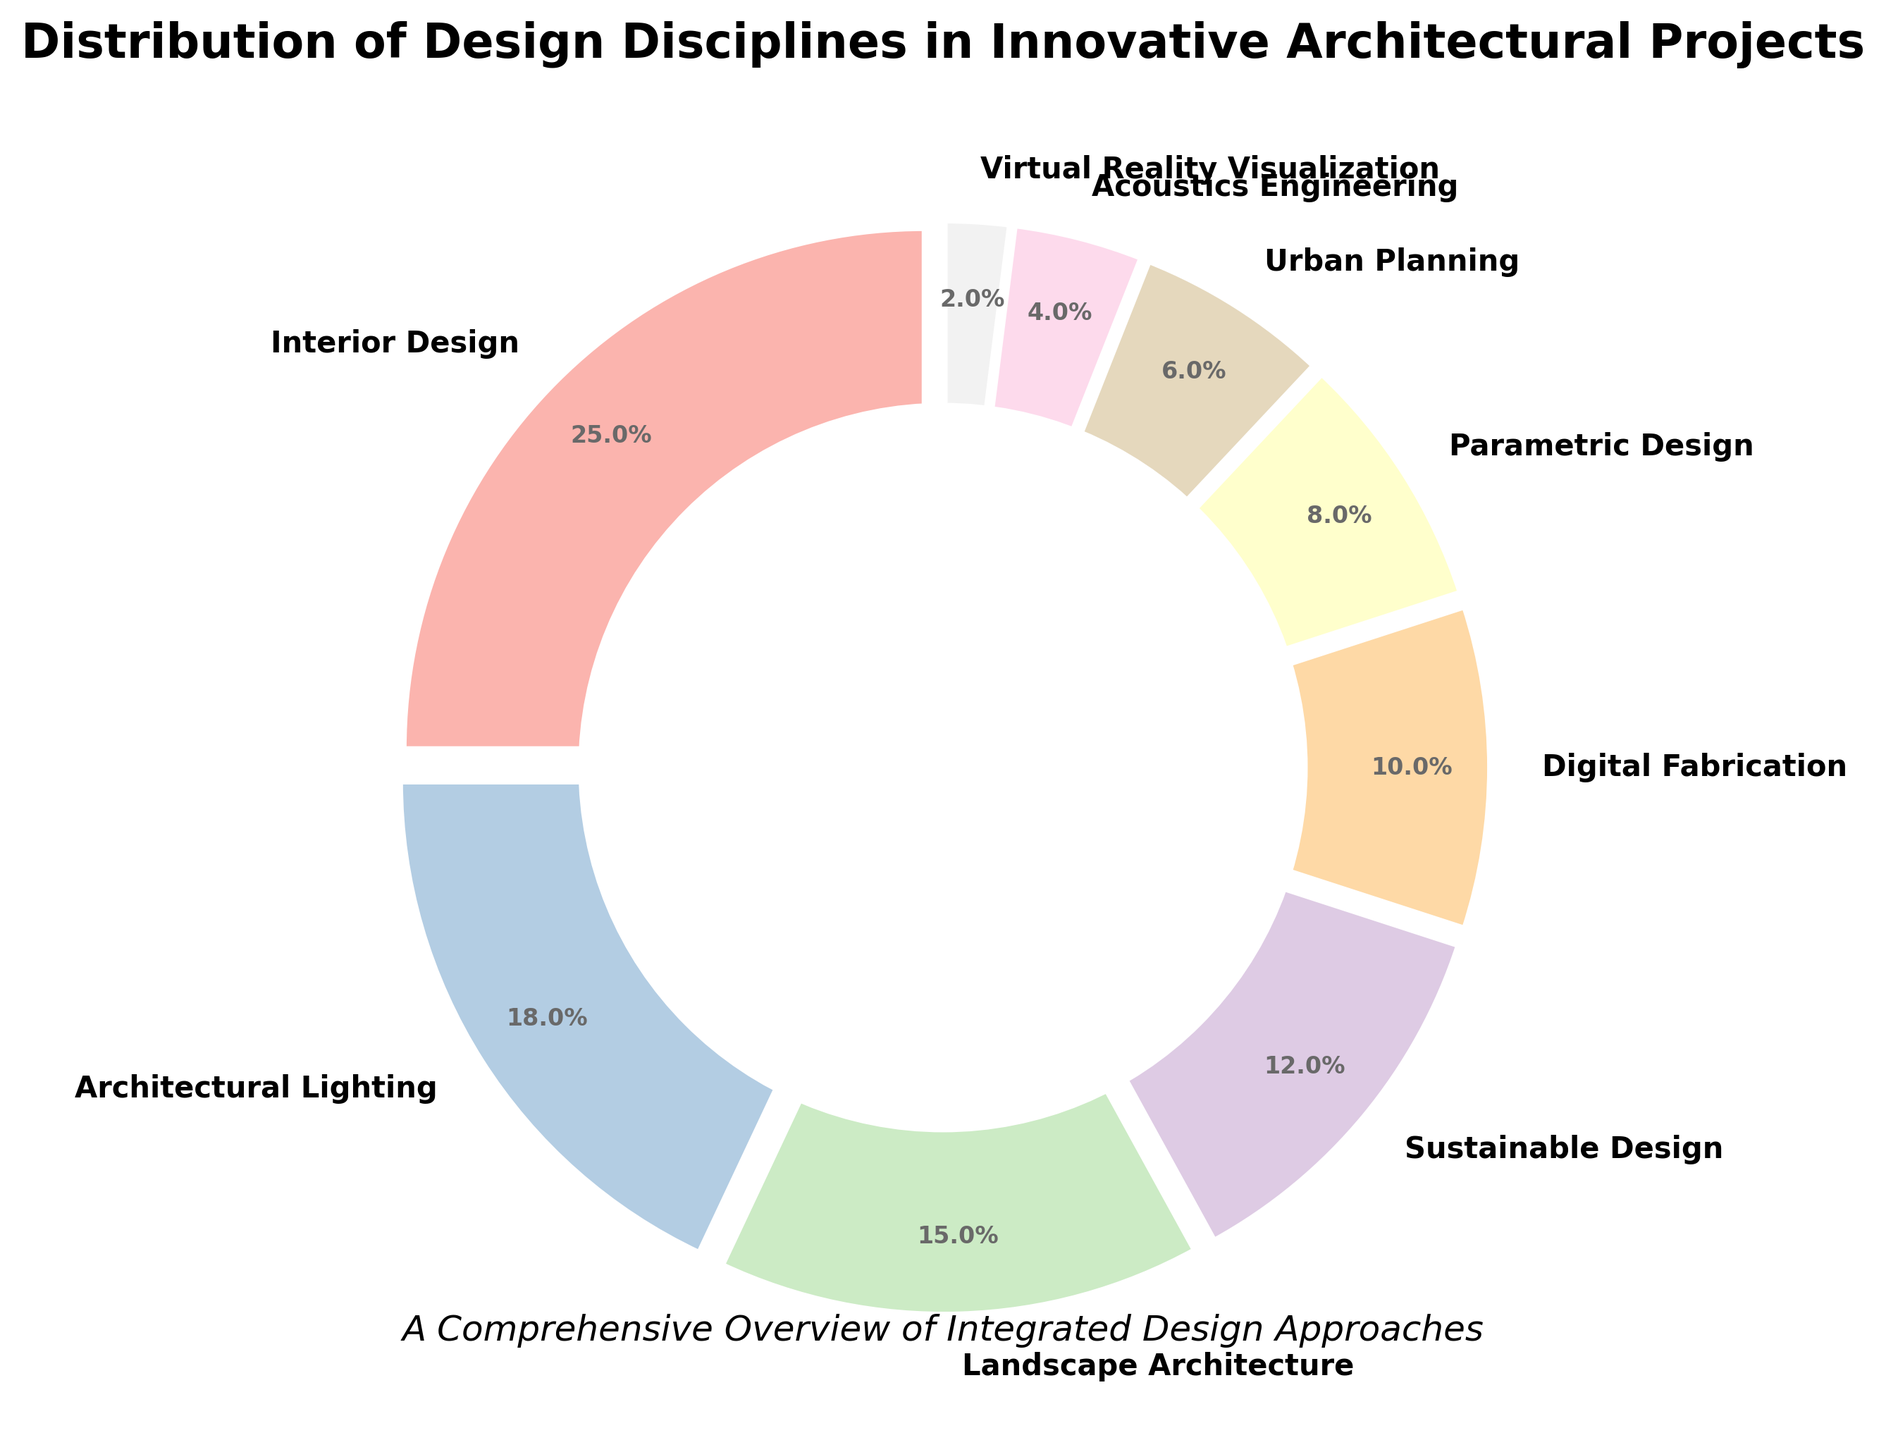Which discipline has the highest percentage? By looking at the pie chart, observe which section is largest. The "Interior Design" section occupies the most space in the chart.
Answer: Interior Design How much more percentage does Interior Design have compared to Urban Planning? The Interior Design section shows 25%, and the Urban Planning section shows 6%. Calculating the difference: 25% - 6% = 19%.
Answer: 19% What is the combined percentage of Sustainable Design and Digital Fabrication? Identifying the percentages from the chart: 12% for Sustainable Design and 10% for Digital Fabrication. Adding them together: 12% + 10% = 22%.
Answer: 22% Which two disciplines together make up half of the total percentage? The chart shows that Interior Design makes up 25% and Architectural Lighting makes up 18%. Combining the two: 25% + 18% = 43%. Interior Design and Landscape Architecture, which is 25% + 15% = 40%, is close too. Hence, no exact pair sums up to 50%, but Interior Design and Architectural Lighting sum up closest to half.
Answer: None How much less is the percentage of Parametric Design compared to Landscape Architecture? The chart shows Parametric Design at 8% and Landscape Architecture at 15%. Calculating the difference: 15% - 8% = 7%.
Answer: 7% Which discipline has the smallest percentage? By looking at the pie chart, observe the smallest section. The "Virtual Reality Visualization" section is the smallest.
Answer: Virtual Reality Visualization What is the total percentage of disciplines focusing on various forms of design (Interior Design, Sustainable Design, Parametric Design, Digital Fabrication)? The chart shows percentages for Interior Design (25%), Sustainable Design (12%), Parametric Design (8%), and Digital Fabrication (10%). Summing these: 25% + 12% + 8% + 10% = 55%.
Answer: 55% How does the percentage of Acoustics Engineering compare to that of Urban Planning? Acoustics Engineering shows 4% while Urban Planning shows 6%. Thus, Acoustics Engineering is less by 2%.
Answer: Less by 2% Compare the combined percentage of Architectural Lighting and Urban Planning to the combined percentage of Landscape Architecture and Acoustics Engineering. Architectural Lighting is 18% and Urban Planning is 6%. Their combined percentage: 18% + 6% = 24%. Landscape Architecture is 15% and Acoustics Engineering is 4%. Their combined percentage: 15% + 4% = 19%. Hence, 24% is greater than 19%.
Answer: Architectural Lighting and Urban Planning combined are greater 